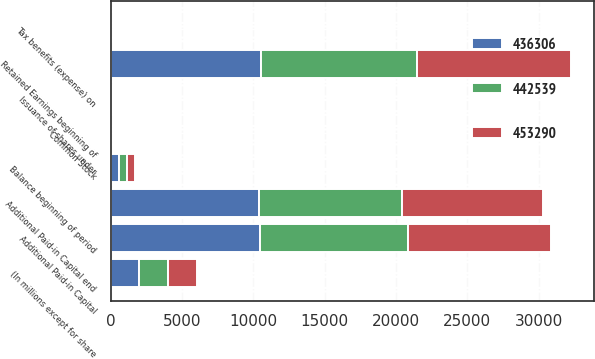Convert chart. <chart><loc_0><loc_0><loc_500><loc_500><stacked_bar_chart><ecel><fcel>(In millions except for share<fcel>Balance beginning of period<fcel>Common Stock<fcel>Additional Paid-in Capital<fcel>Issuance of shares under<fcel>Tax benefits (expense) on<fcel>Additional Paid-in Capital end<fcel>Retained Earnings beginning of<nl><fcel>453290<fcel>2013<fcel>556<fcel>5<fcel>10038<fcel>36<fcel>3<fcel>9894<fcel>10745<nl><fcel>442539<fcel>2012<fcel>556<fcel>5<fcel>10391<fcel>52<fcel>1<fcel>10038<fcel>11001<nl><fcel>436306<fcel>2011<fcel>556<fcel>5<fcel>10448<fcel>50<fcel>7<fcel>10391<fcel>10509<nl></chart> 